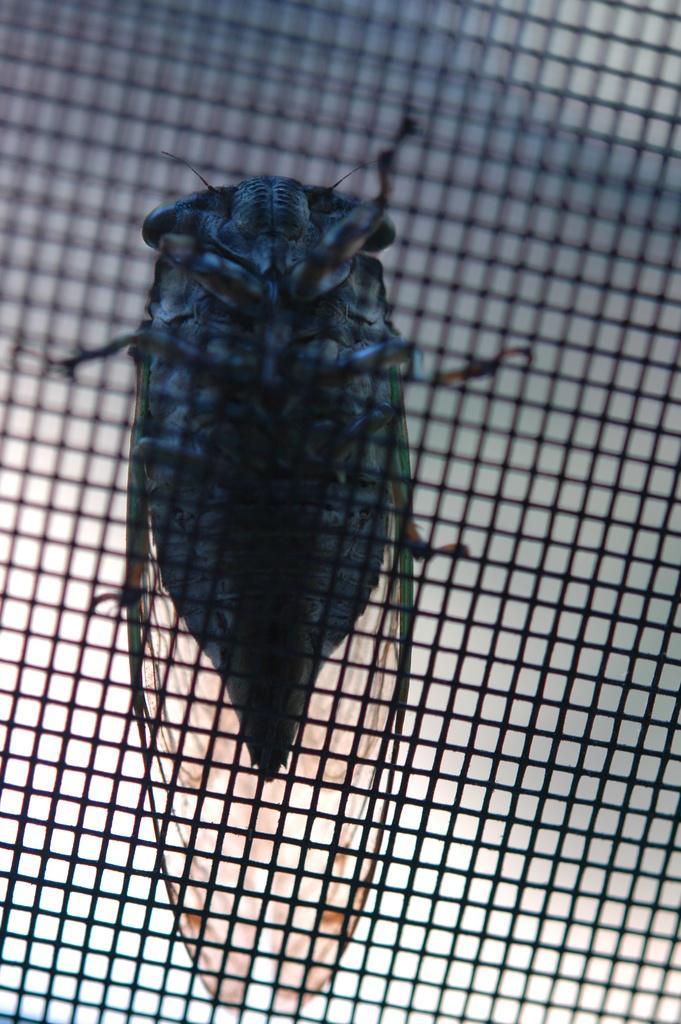Can you describe this image briefly? In the image there is a house fly standing on net. 